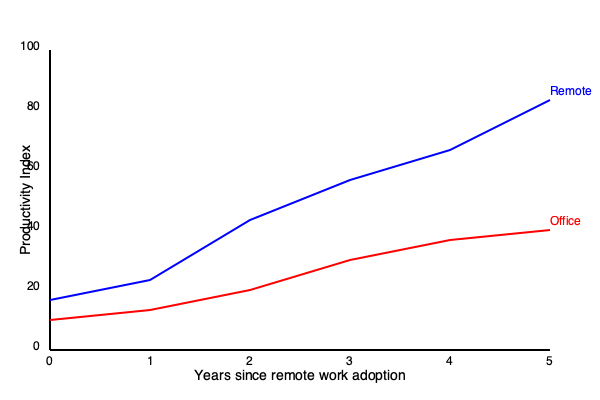Based on the line chart showing remote work and office productivity trends over time, calculate the percentage difference in productivity between remote and office work after 5 years. How does this compare to the initial productivity gap, and what implications might this have for companies considering long-term remote work policies? To answer this question, we need to follow these steps:

1. Identify the initial productivity values:
   - Remote work (blue line): starts at about 20
   - Office work (red line): starts at about 15
   Initial gap = 20 - 15 = 5 points

2. Identify the productivity values after 5 years:
   - Remote work: ends at about 85
   - Office work: ends at about 45

3. Calculate the percentage difference after 5 years:
   Percentage difference = $\frac{\text{Difference}}{\text{Average}} \times 100\%$
   $= \frac{85 - 45}{\frac{85 + 45}{2}} \times 100\%$
   $= \frac{40}{65} \times 100\% \approx 61.5\%$

4. Compare to the initial productivity gap:
   The initial gap was 5 points, which is a smaller absolute difference.
   Initial percentage difference = $\frac{20 - 15}{\frac{20 + 15}{2}} \times 100\% \approx 28.6\%$

5. Implications for companies:
   a. Remote work productivity growth outpaces office work significantly over time.
   b. Initial transition to remote work may have challenges, but long-term benefits are substantial.
   c. Companies may need to reassess their work models to remain competitive.
   d. Investing in remote work infrastructure and policies could lead to higher productivity gains.
   e. The widening gap suggests that remote work skills and processes improve more rapidly than traditional office setups.
Answer: 61.5% difference after 5 years; significant increase from 28.6% initial gap; implies long-term remote work policies could yield substantial productivity gains. 